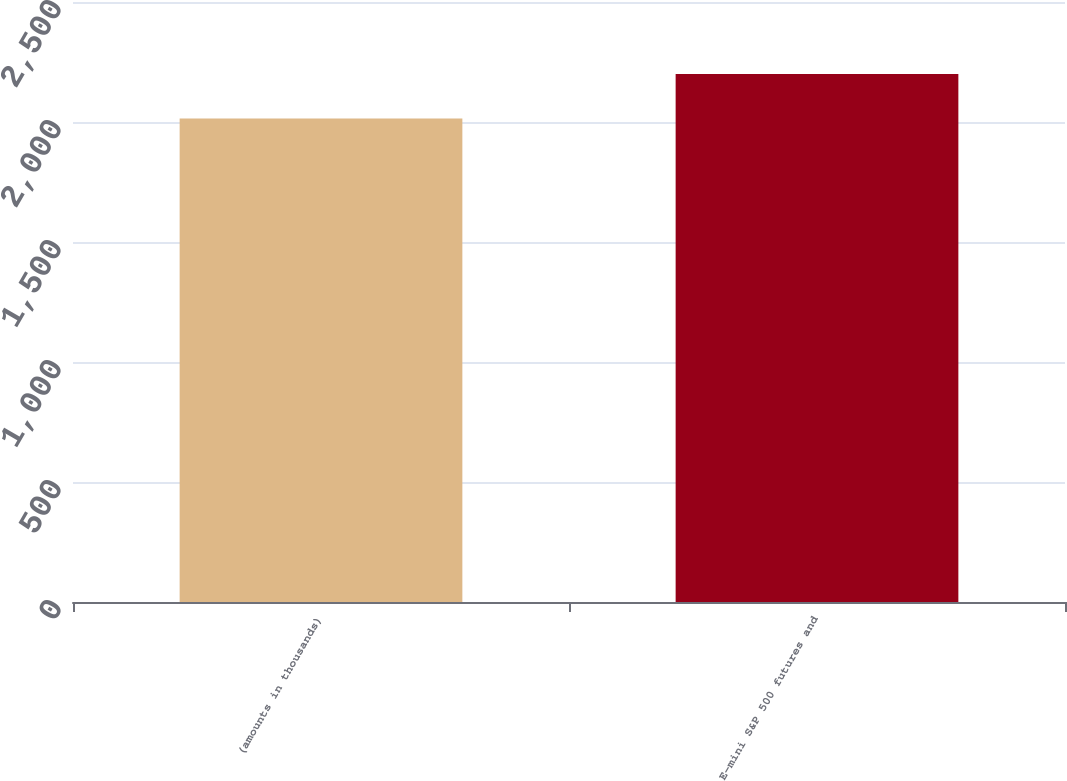Convert chart to OTSL. <chart><loc_0><loc_0><loc_500><loc_500><bar_chart><fcel>(amounts in thousands)<fcel>E-mini S&P 500 futures and<nl><fcel>2015<fcel>2200<nl></chart> 